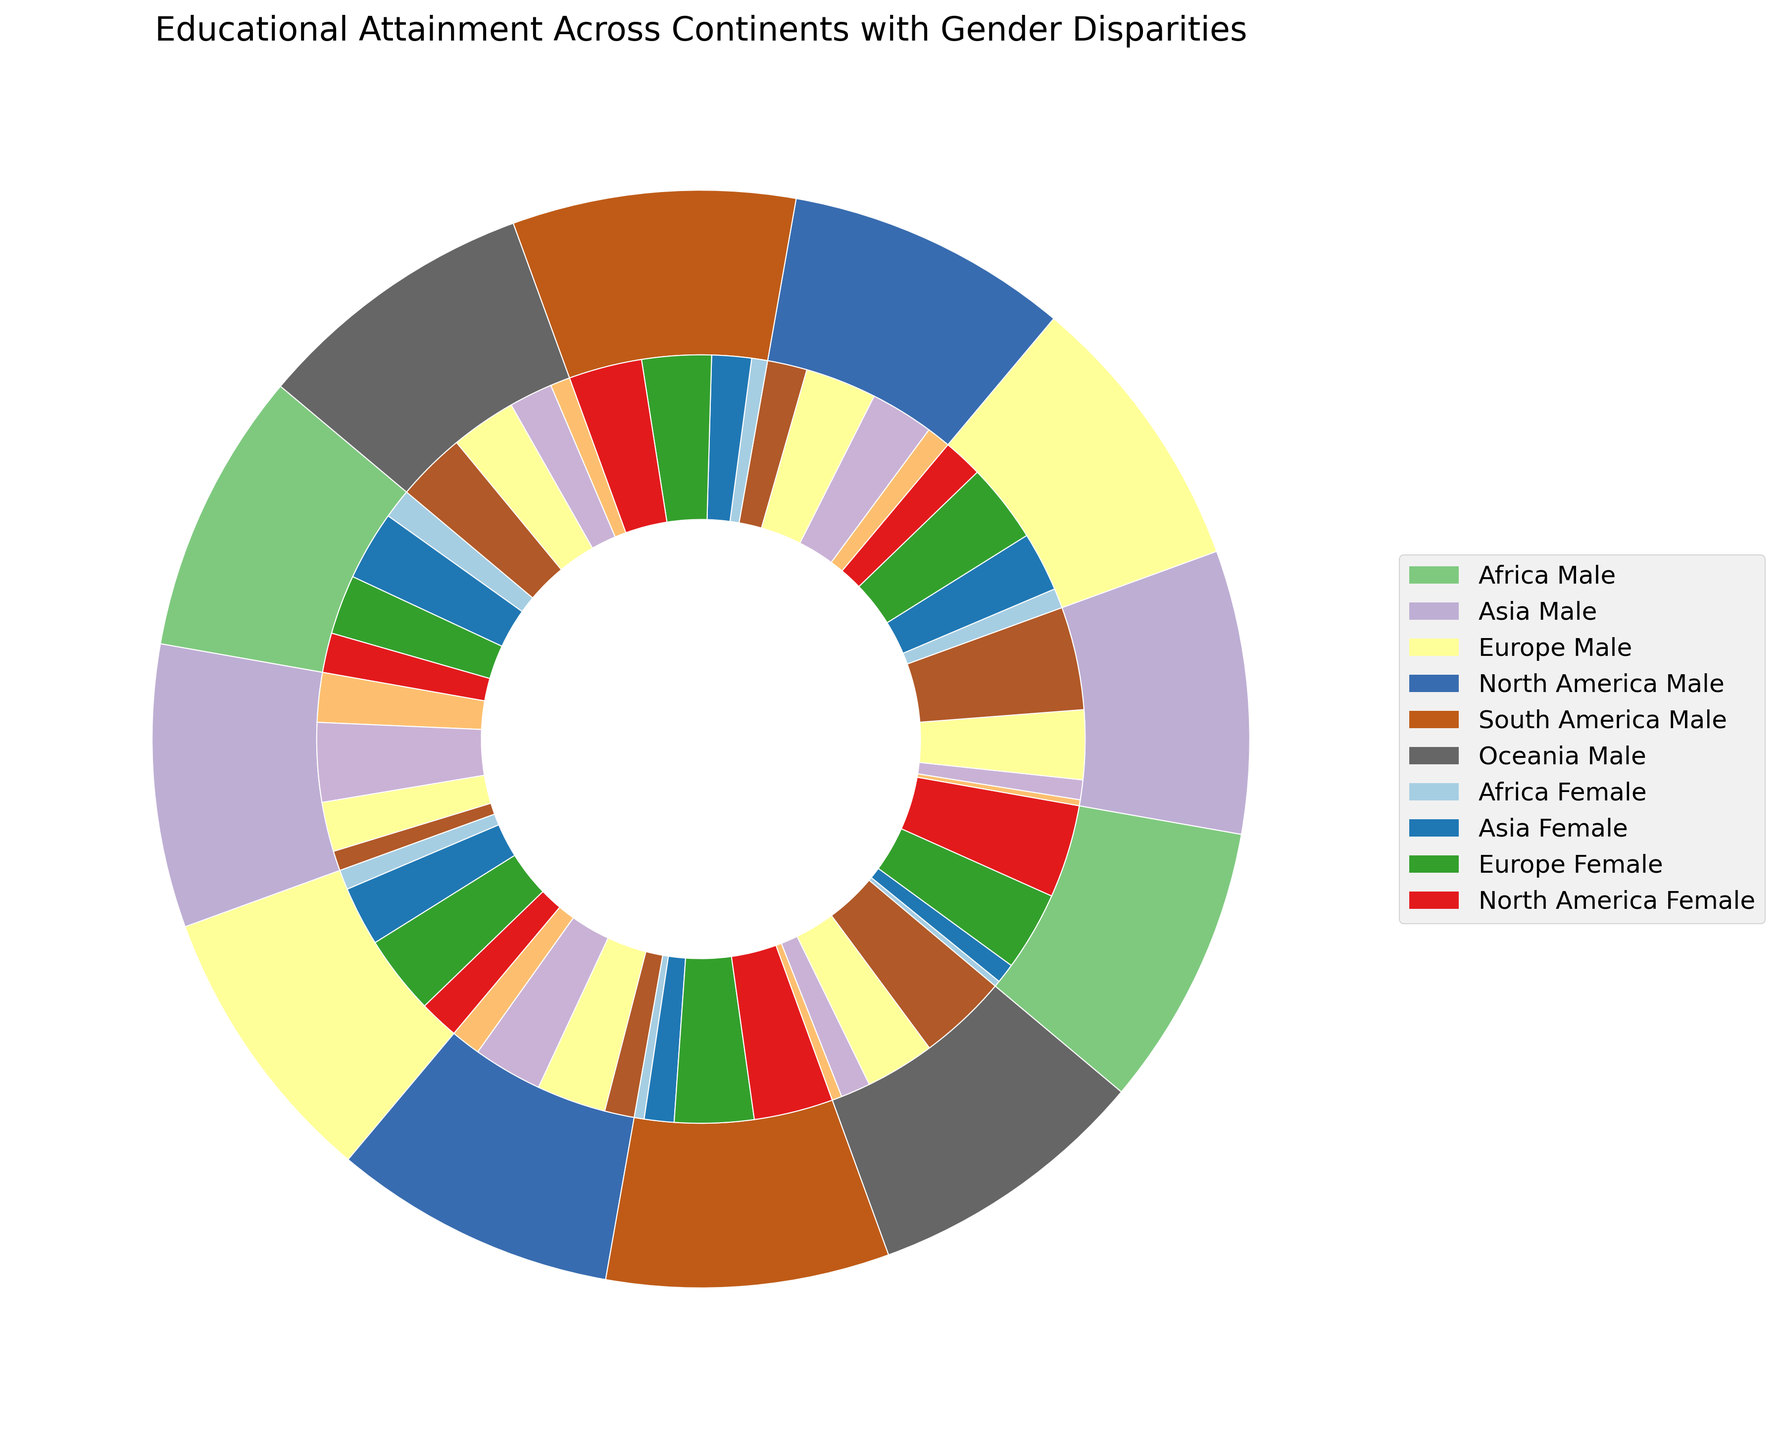Which continent has the smallest percentage of males with no schooling? Look at the outer ring segment colored for males in the continent of North America. This segment is the smallest.
Answer: North America Which group has the highest percentage of individuals with higher education in Europe? Compare the inner circle segments for higher education in Europe for both genders. The segment for females in Europe is bigger than that for males.
Answer: Females What's the difference in the percentages of no schooling between males and females in Africa? The visual representation shows males in Africa at 15% and females at 25%. Subtract the former from the latter. 25% - 15% = 10%
Answer: 10% How does secondary education attainment compare between males in Asia and females in North America? The inner circle should be observed for both continents. Males in Asia have a segment of 40%, and females in North America have a segment of 35%. 40% is greater than 35%.
Answer: Males in Asia have higher secondary education What is the average percentage of primary education attained by males in Asia and South America? Males in Asia have 30%, and males in South America have 30%. The average is (30% + 30%) / 2.
Answer: 30% Which gender has a larger percentage of primary education in Asia? Compare the inner circle segments for primary education in Asia. The segment for females is slightly larger than that for males.
Answer: Females What is the total percentage of people with secondary education in Oceania? Look at the inner circle segments for secondary education in Oceania for both genders. Males have 35%, and females have 33%. Add these together. 35% + 33% = 68%
Answer: 68% Which continent shows the smallest gender disparity in higher education? Compare the segments for higher education for both genders across all continents. Europe shows a close percentage between males (40%) and females (45%).
Answer: Europe In which continent do females have higher percentages than males across all education levels? Compare all segments for education levels across the continents. Africa, where females have higher percentages than males in all categories.
Answer: Africa 